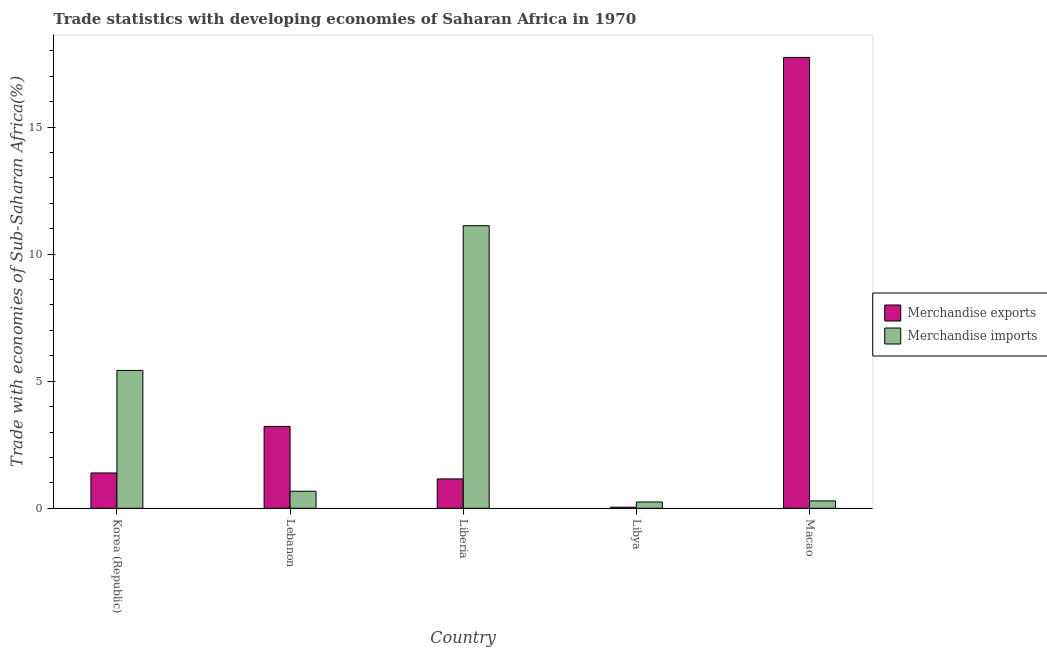How many different coloured bars are there?
Offer a very short reply. 2. Are the number of bars per tick equal to the number of legend labels?
Offer a terse response. Yes. What is the label of the 5th group of bars from the left?
Keep it short and to the point. Macao. What is the merchandise exports in Lebanon?
Your response must be concise. 3.22. Across all countries, what is the maximum merchandise exports?
Make the answer very short. 17.74. Across all countries, what is the minimum merchandise exports?
Provide a short and direct response. 0.04. In which country was the merchandise imports maximum?
Give a very brief answer. Liberia. In which country was the merchandise exports minimum?
Your answer should be very brief. Libya. What is the total merchandise imports in the graph?
Your response must be concise. 17.75. What is the difference between the merchandise exports in Liberia and that in Libya?
Provide a succinct answer. 1.11. What is the difference between the merchandise exports in Macao and the merchandise imports in Liberia?
Your answer should be compact. 6.62. What is the average merchandise imports per country?
Your answer should be very brief. 3.55. What is the difference between the merchandise imports and merchandise exports in Macao?
Offer a terse response. -17.45. In how many countries, is the merchandise exports greater than 12 %?
Your answer should be compact. 1. What is the ratio of the merchandise imports in Korea (Republic) to that in Lebanon?
Offer a very short reply. 8.1. Is the merchandise exports in Lebanon less than that in Macao?
Provide a short and direct response. Yes. What is the difference between the highest and the second highest merchandise exports?
Your answer should be compact. 14.52. What is the difference between the highest and the lowest merchandise imports?
Provide a succinct answer. 10.87. In how many countries, is the merchandise exports greater than the average merchandise exports taken over all countries?
Offer a terse response. 1. How many bars are there?
Offer a very short reply. 10. What is the difference between two consecutive major ticks on the Y-axis?
Your answer should be compact. 5. Are the values on the major ticks of Y-axis written in scientific E-notation?
Your answer should be compact. No. Does the graph contain grids?
Ensure brevity in your answer.  No. Where does the legend appear in the graph?
Ensure brevity in your answer.  Center right. How many legend labels are there?
Offer a very short reply. 2. What is the title of the graph?
Offer a very short reply. Trade statistics with developing economies of Saharan Africa in 1970. Does "Central government" appear as one of the legend labels in the graph?
Your answer should be compact. No. What is the label or title of the Y-axis?
Provide a short and direct response. Trade with economies of Sub-Saharan Africa(%). What is the Trade with economies of Sub-Saharan Africa(%) of Merchandise exports in Korea (Republic)?
Ensure brevity in your answer.  1.39. What is the Trade with economies of Sub-Saharan Africa(%) in Merchandise imports in Korea (Republic)?
Your answer should be very brief. 5.42. What is the Trade with economies of Sub-Saharan Africa(%) in Merchandise exports in Lebanon?
Keep it short and to the point. 3.22. What is the Trade with economies of Sub-Saharan Africa(%) in Merchandise imports in Lebanon?
Make the answer very short. 0.67. What is the Trade with economies of Sub-Saharan Africa(%) of Merchandise exports in Liberia?
Your answer should be very brief. 1.15. What is the Trade with economies of Sub-Saharan Africa(%) of Merchandise imports in Liberia?
Offer a very short reply. 11.12. What is the Trade with economies of Sub-Saharan Africa(%) in Merchandise exports in Libya?
Give a very brief answer. 0.04. What is the Trade with economies of Sub-Saharan Africa(%) of Merchandise imports in Libya?
Provide a short and direct response. 0.25. What is the Trade with economies of Sub-Saharan Africa(%) in Merchandise exports in Macao?
Your answer should be compact. 17.74. What is the Trade with economies of Sub-Saharan Africa(%) of Merchandise imports in Macao?
Your response must be concise. 0.29. Across all countries, what is the maximum Trade with economies of Sub-Saharan Africa(%) of Merchandise exports?
Make the answer very short. 17.74. Across all countries, what is the maximum Trade with economies of Sub-Saharan Africa(%) of Merchandise imports?
Your answer should be compact. 11.12. Across all countries, what is the minimum Trade with economies of Sub-Saharan Africa(%) of Merchandise exports?
Keep it short and to the point. 0.04. Across all countries, what is the minimum Trade with economies of Sub-Saharan Africa(%) of Merchandise imports?
Ensure brevity in your answer.  0.25. What is the total Trade with economies of Sub-Saharan Africa(%) in Merchandise exports in the graph?
Offer a terse response. 23.55. What is the total Trade with economies of Sub-Saharan Africa(%) in Merchandise imports in the graph?
Your answer should be very brief. 17.75. What is the difference between the Trade with economies of Sub-Saharan Africa(%) of Merchandise exports in Korea (Republic) and that in Lebanon?
Your answer should be compact. -1.83. What is the difference between the Trade with economies of Sub-Saharan Africa(%) of Merchandise imports in Korea (Republic) and that in Lebanon?
Offer a terse response. 4.75. What is the difference between the Trade with economies of Sub-Saharan Africa(%) in Merchandise exports in Korea (Republic) and that in Liberia?
Provide a short and direct response. 0.24. What is the difference between the Trade with economies of Sub-Saharan Africa(%) of Merchandise imports in Korea (Republic) and that in Liberia?
Make the answer very short. -5.7. What is the difference between the Trade with economies of Sub-Saharan Africa(%) of Merchandise exports in Korea (Republic) and that in Libya?
Give a very brief answer. 1.35. What is the difference between the Trade with economies of Sub-Saharan Africa(%) of Merchandise imports in Korea (Republic) and that in Libya?
Give a very brief answer. 5.18. What is the difference between the Trade with economies of Sub-Saharan Africa(%) of Merchandise exports in Korea (Republic) and that in Macao?
Offer a terse response. -16.35. What is the difference between the Trade with economies of Sub-Saharan Africa(%) of Merchandise imports in Korea (Republic) and that in Macao?
Ensure brevity in your answer.  5.13. What is the difference between the Trade with economies of Sub-Saharan Africa(%) of Merchandise exports in Lebanon and that in Liberia?
Ensure brevity in your answer.  2.07. What is the difference between the Trade with economies of Sub-Saharan Africa(%) of Merchandise imports in Lebanon and that in Liberia?
Provide a short and direct response. -10.45. What is the difference between the Trade with economies of Sub-Saharan Africa(%) in Merchandise exports in Lebanon and that in Libya?
Ensure brevity in your answer.  3.18. What is the difference between the Trade with economies of Sub-Saharan Africa(%) of Merchandise imports in Lebanon and that in Libya?
Offer a very short reply. 0.42. What is the difference between the Trade with economies of Sub-Saharan Africa(%) in Merchandise exports in Lebanon and that in Macao?
Offer a terse response. -14.52. What is the difference between the Trade with economies of Sub-Saharan Africa(%) in Merchandise imports in Lebanon and that in Macao?
Provide a succinct answer. 0.38. What is the difference between the Trade with economies of Sub-Saharan Africa(%) of Merchandise exports in Liberia and that in Libya?
Provide a succinct answer. 1.11. What is the difference between the Trade with economies of Sub-Saharan Africa(%) in Merchandise imports in Liberia and that in Libya?
Offer a very short reply. 10.87. What is the difference between the Trade with economies of Sub-Saharan Africa(%) of Merchandise exports in Liberia and that in Macao?
Your response must be concise. -16.59. What is the difference between the Trade with economies of Sub-Saharan Africa(%) in Merchandise imports in Liberia and that in Macao?
Offer a very short reply. 10.83. What is the difference between the Trade with economies of Sub-Saharan Africa(%) of Merchandise exports in Libya and that in Macao?
Make the answer very short. -17.7. What is the difference between the Trade with economies of Sub-Saharan Africa(%) in Merchandise imports in Libya and that in Macao?
Offer a very short reply. -0.04. What is the difference between the Trade with economies of Sub-Saharan Africa(%) of Merchandise exports in Korea (Republic) and the Trade with economies of Sub-Saharan Africa(%) of Merchandise imports in Lebanon?
Make the answer very short. 0.72. What is the difference between the Trade with economies of Sub-Saharan Africa(%) of Merchandise exports in Korea (Republic) and the Trade with economies of Sub-Saharan Africa(%) of Merchandise imports in Liberia?
Offer a terse response. -9.73. What is the difference between the Trade with economies of Sub-Saharan Africa(%) in Merchandise exports in Korea (Republic) and the Trade with economies of Sub-Saharan Africa(%) in Merchandise imports in Libya?
Ensure brevity in your answer.  1.14. What is the difference between the Trade with economies of Sub-Saharan Africa(%) of Merchandise exports in Korea (Republic) and the Trade with economies of Sub-Saharan Africa(%) of Merchandise imports in Macao?
Ensure brevity in your answer.  1.1. What is the difference between the Trade with economies of Sub-Saharan Africa(%) of Merchandise exports in Lebanon and the Trade with economies of Sub-Saharan Africa(%) of Merchandise imports in Liberia?
Provide a short and direct response. -7.9. What is the difference between the Trade with economies of Sub-Saharan Africa(%) in Merchandise exports in Lebanon and the Trade with economies of Sub-Saharan Africa(%) in Merchandise imports in Libya?
Your response must be concise. 2.97. What is the difference between the Trade with economies of Sub-Saharan Africa(%) of Merchandise exports in Lebanon and the Trade with economies of Sub-Saharan Africa(%) of Merchandise imports in Macao?
Make the answer very short. 2.93. What is the difference between the Trade with economies of Sub-Saharan Africa(%) in Merchandise exports in Liberia and the Trade with economies of Sub-Saharan Africa(%) in Merchandise imports in Libya?
Give a very brief answer. 0.91. What is the difference between the Trade with economies of Sub-Saharan Africa(%) in Merchandise exports in Liberia and the Trade with economies of Sub-Saharan Africa(%) in Merchandise imports in Macao?
Ensure brevity in your answer.  0.86. What is the difference between the Trade with economies of Sub-Saharan Africa(%) in Merchandise exports in Libya and the Trade with economies of Sub-Saharan Africa(%) in Merchandise imports in Macao?
Your answer should be compact. -0.25. What is the average Trade with economies of Sub-Saharan Africa(%) of Merchandise exports per country?
Give a very brief answer. 4.71. What is the average Trade with economies of Sub-Saharan Africa(%) of Merchandise imports per country?
Your answer should be compact. 3.55. What is the difference between the Trade with economies of Sub-Saharan Africa(%) of Merchandise exports and Trade with economies of Sub-Saharan Africa(%) of Merchandise imports in Korea (Republic)?
Make the answer very short. -4.03. What is the difference between the Trade with economies of Sub-Saharan Africa(%) of Merchandise exports and Trade with economies of Sub-Saharan Africa(%) of Merchandise imports in Lebanon?
Give a very brief answer. 2.55. What is the difference between the Trade with economies of Sub-Saharan Africa(%) in Merchandise exports and Trade with economies of Sub-Saharan Africa(%) in Merchandise imports in Liberia?
Ensure brevity in your answer.  -9.96. What is the difference between the Trade with economies of Sub-Saharan Africa(%) of Merchandise exports and Trade with economies of Sub-Saharan Africa(%) of Merchandise imports in Libya?
Ensure brevity in your answer.  -0.2. What is the difference between the Trade with economies of Sub-Saharan Africa(%) of Merchandise exports and Trade with economies of Sub-Saharan Africa(%) of Merchandise imports in Macao?
Provide a short and direct response. 17.45. What is the ratio of the Trade with economies of Sub-Saharan Africa(%) of Merchandise exports in Korea (Republic) to that in Lebanon?
Offer a terse response. 0.43. What is the ratio of the Trade with economies of Sub-Saharan Africa(%) in Merchandise imports in Korea (Republic) to that in Lebanon?
Ensure brevity in your answer.  8.1. What is the ratio of the Trade with economies of Sub-Saharan Africa(%) of Merchandise exports in Korea (Republic) to that in Liberia?
Provide a succinct answer. 1.2. What is the ratio of the Trade with economies of Sub-Saharan Africa(%) in Merchandise imports in Korea (Republic) to that in Liberia?
Give a very brief answer. 0.49. What is the ratio of the Trade with economies of Sub-Saharan Africa(%) of Merchandise exports in Korea (Republic) to that in Libya?
Your answer should be compact. 32.87. What is the ratio of the Trade with economies of Sub-Saharan Africa(%) of Merchandise imports in Korea (Republic) to that in Libya?
Provide a succinct answer. 21.98. What is the ratio of the Trade with economies of Sub-Saharan Africa(%) of Merchandise exports in Korea (Republic) to that in Macao?
Offer a very short reply. 0.08. What is the ratio of the Trade with economies of Sub-Saharan Africa(%) of Merchandise imports in Korea (Republic) to that in Macao?
Provide a short and direct response. 18.74. What is the ratio of the Trade with economies of Sub-Saharan Africa(%) of Merchandise exports in Lebanon to that in Liberia?
Your response must be concise. 2.79. What is the ratio of the Trade with economies of Sub-Saharan Africa(%) in Merchandise imports in Lebanon to that in Liberia?
Ensure brevity in your answer.  0.06. What is the ratio of the Trade with economies of Sub-Saharan Africa(%) in Merchandise exports in Lebanon to that in Libya?
Your response must be concise. 76.16. What is the ratio of the Trade with economies of Sub-Saharan Africa(%) of Merchandise imports in Lebanon to that in Libya?
Your answer should be compact. 2.71. What is the ratio of the Trade with economies of Sub-Saharan Africa(%) of Merchandise exports in Lebanon to that in Macao?
Give a very brief answer. 0.18. What is the ratio of the Trade with economies of Sub-Saharan Africa(%) of Merchandise imports in Lebanon to that in Macao?
Provide a short and direct response. 2.31. What is the ratio of the Trade with economies of Sub-Saharan Africa(%) of Merchandise exports in Liberia to that in Libya?
Give a very brief answer. 27.31. What is the ratio of the Trade with economies of Sub-Saharan Africa(%) in Merchandise imports in Liberia to that in Libya?
Keep it short and to the point. 45.05. What is the ratio of the Trade with economies of Sub-Saharan Africa(%) of Merchandise exports in Liberia to that in Macao?
Keep it short and to the point. 0.07. What is the ratio of the Trade with economies of Sub-Saharan Africa(%) of Merchandise imports in Liberia to that in Macao?
Ensure brevity in your answer.  38.42. What is the ratio of the Trade with economies of Sub-Saharan Africa(%) in Merchandise exports in Libya to that in Macao?
Your answer should be compact. 0. What is the ratio of the Trade with economies of Sub-Saharan Africa(%) of Merchandise imports in Libya to that in Macao?
Offer a terse response. 0.85. What is the difference between the highest and the second highest Trade with economies of Sub-Saharan Africa(%) in Merchandise exports?
Your answer should be very brief. 14.52. What is the difference between the highest and the second highest Trade with economies of Sub-Saharan Africa(%) in Merchandise imports?
Make the answer very short. 5.7. What is the difference between the highest and the lowest Trade with economies of Sub-Saharan Africa(%) in Merchandise exports?
Your response must be concise. 17.7. What is the difference between the highest and the lowest Trade with economies of Sub-Saharan Africa(%) in Merchandise imports?
Your answer should be compact. 10.87. 